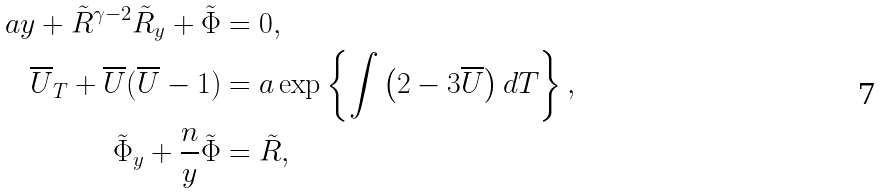Convert formula to latex. <formula><loc_0><loc_0><loc_500><loc_500>a y + \tilde { R } ^ { \gamma - 2 } \tilde { R } _ { y } + \tilde { \Phi } & = 0 , \\ \overline { U } _ { T } + \overline { U } ( \overline { U } - 1 ) & = a \exp \left \{ \int \left ( 2 - 3 \overline { U } \right ) d T \right \} , \\ \tilde { \Phi } _ { y } + \frac { n } { y } \tilde { \Phi } & = \tilde { R } ,</formula> 